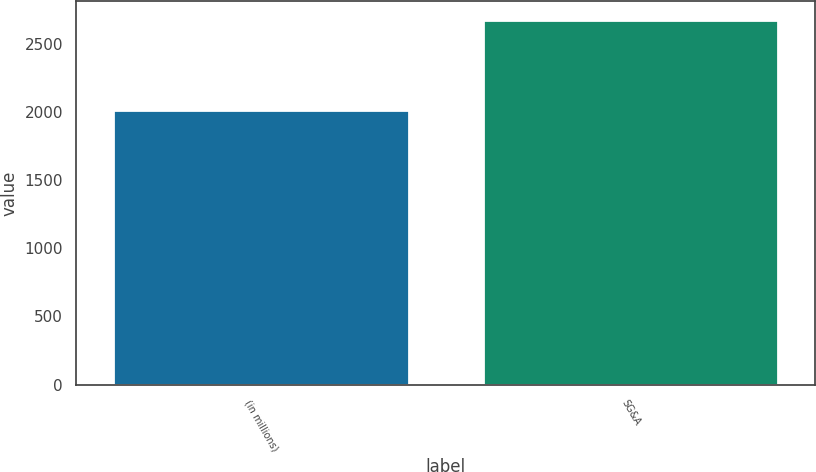<chart> <loc_0><loc_0><loc_500><loc_500><bar_chart><fcel>(in millions)<fcel>SG&A<nl><fcel>2012<fcel>2677<nl></chart> 